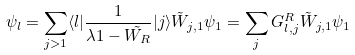Convert formula to latex. <formula><loc_0><loc_0><loc_500><loc_500>\psi _ { l } = \sum _ { j > 1 } \langle l | \frac { 1 } { \lambda { 1 } - \tilde { W _ { R } } } | j \rangle \tilde { W } _ { j , 1 } \psi _ { 1 } = \sum _ { j } G ^ { R } _ { l , j } \tilde { W } _ { j , 1 } \psi _ { 1 }</formula> 